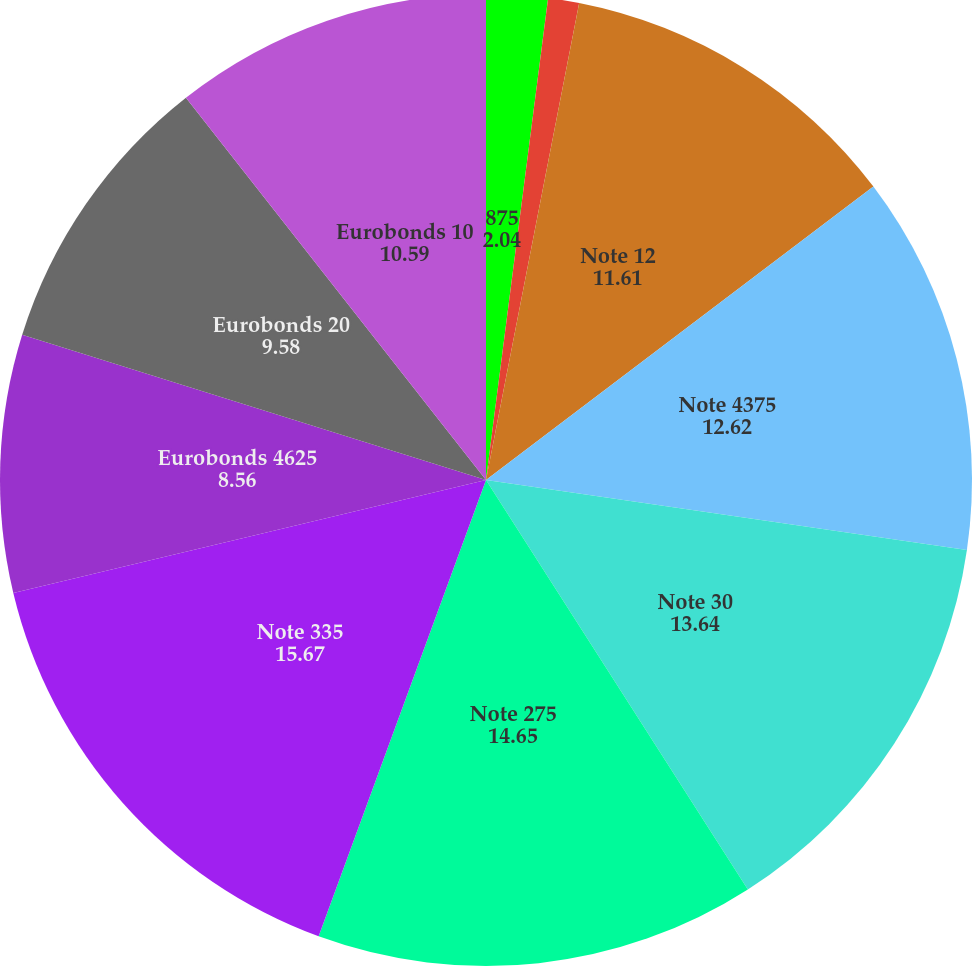<chart> <loc_0><loc_0><loc_500><loc_500><pie_chart><fcel>875<fcel>Series E 76<fcel>Note 12<fcel>Note 4375<fcel>Note 30<fcel>Note 275<fcel>Note 335<fcel>Eurobonds 4625<fcel>Eurobonds 20<fcel>Eurobonds 10<nl><fcel>2.04%<fcel>1.03%<fcel>11.61%<fcel>12.62%<fcel>13.64%<fcel>14.65%<fcel>15.67%<fcel>8.56%<fcel>9.58%<fcel>10.59%<nl></chart> 